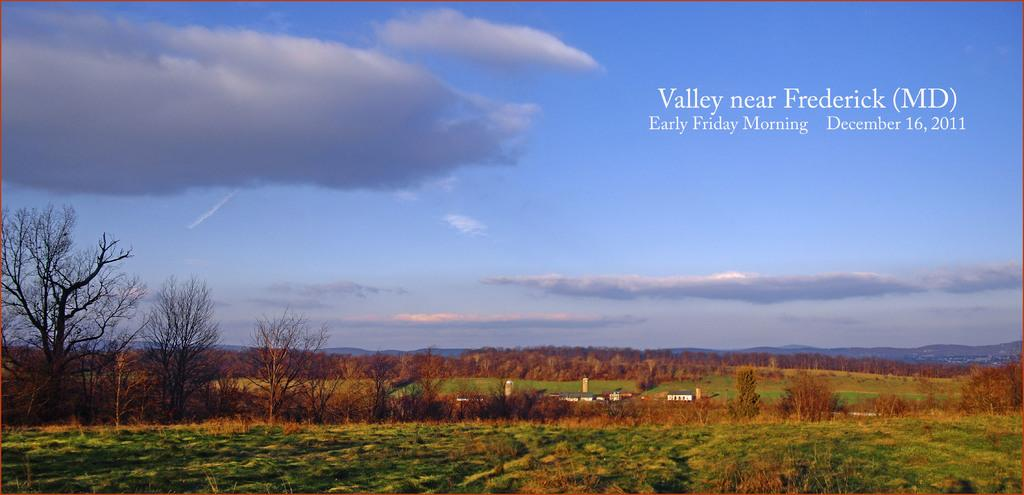What type of vegetation can be seen in the image? There is a group of trees, plants, and grass visible in the image. What type of structures are present in the image? There are buildings in the image. What type of terrain can be seen in the image? There are hills in the image. What is visible in the sky in the image? The sky is visible in the image, and it appears cloudy. Is there any text present in the image? Yes, there is text present in the image. Can you see a crow perched on a swing in the image? There is no swing or crow present in the image. What color is the leaf on the tree in the image? There is no leaf mentioned in the provided facts, and the image does not show a specific leaf to describe its color. 